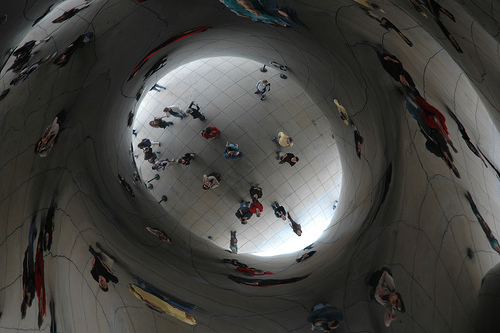<image>
Is there a person next to the reflection? Yes. The person is positioned adjacent to the reflection, located nearby in the same general area. 